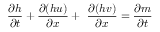<formula> <loc_0><loc_0><loc_500><loc_500>\frac { \partial h } { \partial t } + \frac { \partial ( h u ) } { \partial x } + \ \frac { \partial ( h v ) } { \partial x } = \frac { \partial m } { \partial t }</formula> 